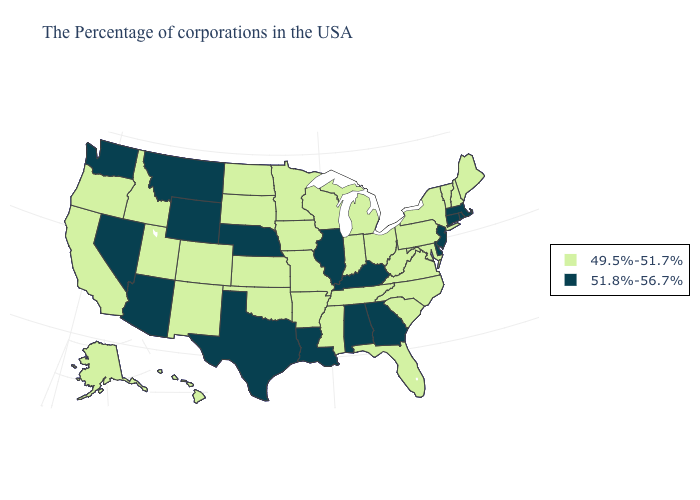Does Maine have a higher value than Delaware?
Answer briefly. No. Name the states that have a value in the range 49.5%-51.7%?
Give a very brief answer. Maine, New Hampshire, Vermont, New York, Maryland, Pennsylvania, Virginia, North Carolina, South Carolina, West Virginia, Ohio, Florida, Michigan, Indiana, Tennessee, Wisconsin, Mississippi, Missouri, Arkansas, Minnesota, Iowa, Kansas, Oklahoma, South Dakota, North Dakota, Colorado, New Mexico, Utah, Idaho, California, Oregon, Alaska, Hawaii. Does Illinois have a higher value than Nevada?
Quick response, please. No. Name the states that have a value in the range 49.5%-51.7%?
Give a very brief answer. Maine, New Hampshire, Vermont, New York, Maryland, Pennsylvania, Virginia, North Carolina, South Carolina, West Virginia, Ohio, Florida, Michigan, Indiana, Tennessee, Wisconsin, Mississippi, Missouri, Arkansas, Minnesota, Iowa, Kansas, Oklahoma, South Dakota, North Dakota, Colorado, New Mexico, Utah, Idaho, California, Oregon, Alaska, Hawaii. Name the states that have a value in the range 49.5%-51.7%?
Write a very short answer. Maine, New Hampshire, Vermont, New York, Maryland, Pennsylvania, Virginia, North Carolina, South Carolina, West Virginia, Ohio, Florida, Michigan, Indiana, Tennessee, Wisconsin, Mississippi, Missouri, Arkansas, Minnesota, Iowa, Kansas, Oklahoma, South Dakota, North Dakota, Colorado, New Mexico, Utah, Idaho, California, Oregon, Alaska, Hawaii. What is the value of Arizona?
Be succinct. 51.8%-56.7%. What is the value of South Dakota?
Write a very short answer. 49.5%-51.7%. What is the value of North Carolina?
Quick response, please. 49.5%-51.7%. What is the value of New Jersey?
Give a very brief answer. 51.8%-56.7%. Does the map have missing data?
Answer briefly. No. Does Alaska have the same value as North Dakota?
Concise answer only. Yes. Does the first symbol in the legend represent the smallest category?
Concise answer only. Yes. What is the value of Utah?
Be succinct. 49.5%-51.7%. Does Rhode Island have the highest value in the Northeast?
Give a very brief answer. Yes. Which states have the lowest value in the Northeast?
Concise answer only. Maine, New Hampshire, Vermont, New York, Pennsylvania. 